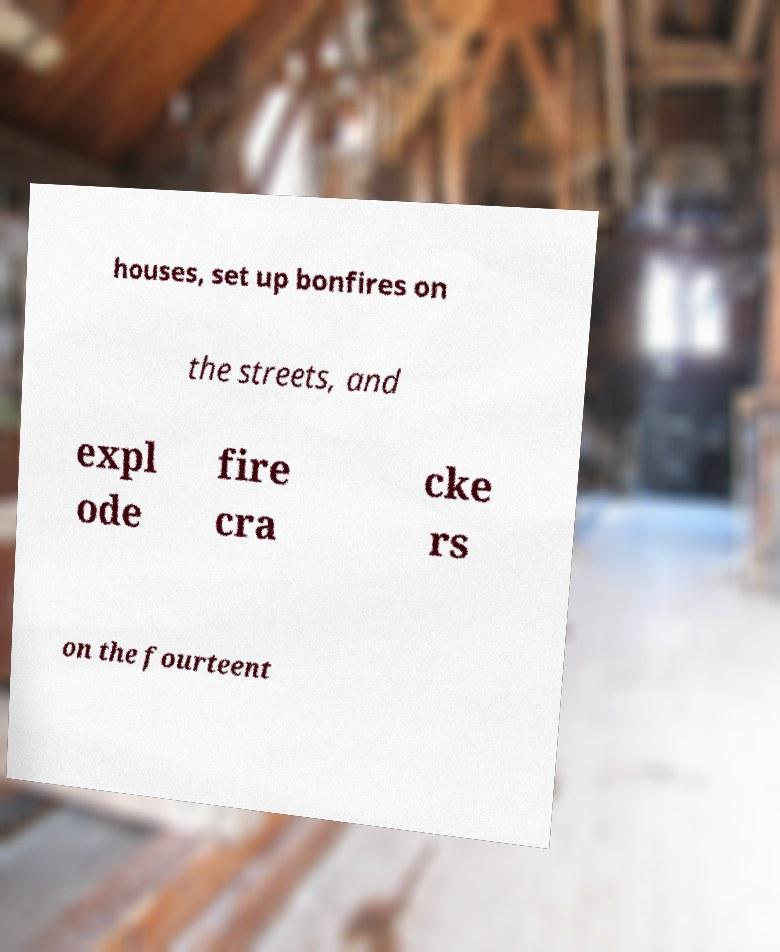Could you extract and type out the text from this image? houses, set up bonfires on the streets, and expl ode fire cra cke rs on the fourteent 